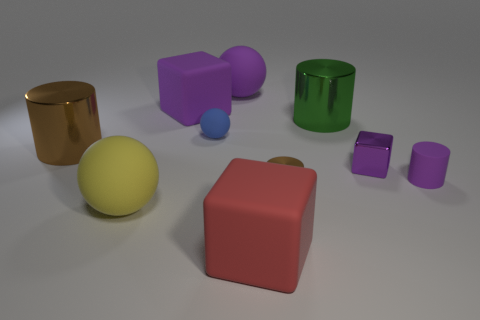Subtract all red balls. Subtract all purple cubes. How many balls are left? 3 Subtract all cubes. How many objects are left? 7 Subtract all green matte cubes. Subtract all blue balls. How many objects are left? 9 Add 6 yellow things. How many yellow things are left? 7 Add 5 blue matte spheres. How many blue matte spheres exist? 6 Subtract 0 brown cubes. How many objects are left? 10 